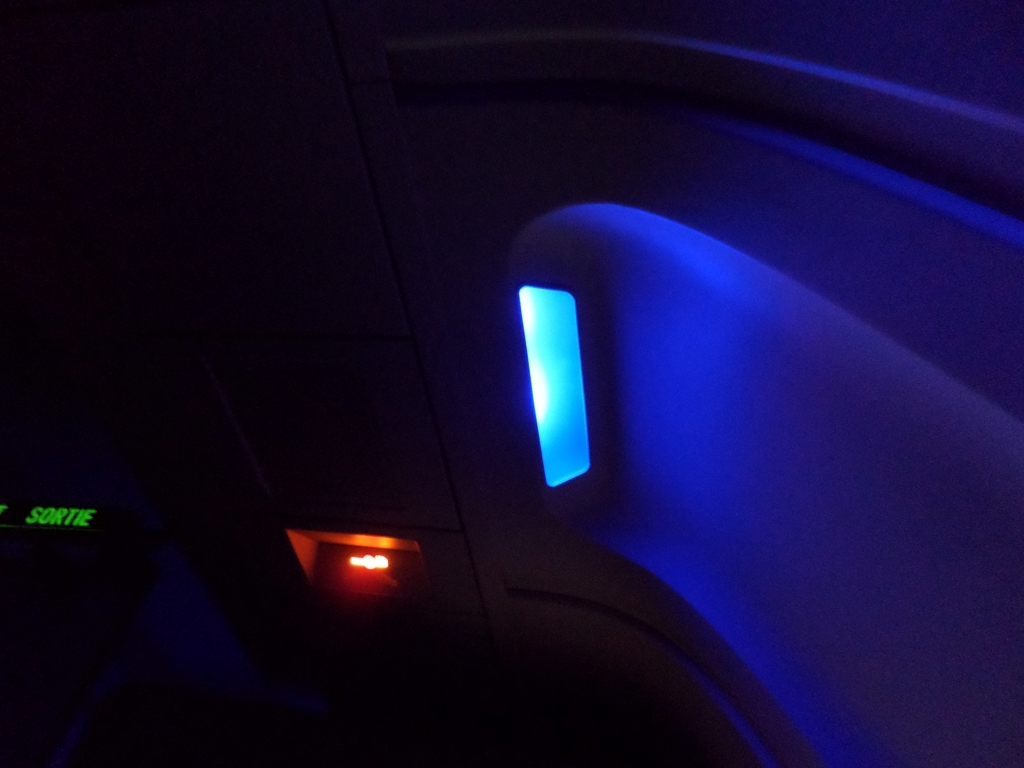How does the design of the light feature contribute to passenger comfort and safety? The light feature's design, with its soft glow and strategic placement, likely contributes to passenger comfort by providing gentle illumination that's easy on the eyes, reducing strain during a potentially long flight. Safety-wise, it also helps maintain enough visibility for passengers to navigate the cabin if needed, without disturbing the rest of the cabin. 